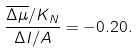Convert formula to latex. <formula><loc_0><loc_0><loc_500><loc_500>\frac { \overline { \Delta \mu } / K _ { N } } { \Delta I / A } = - 0 . 2 0 .</formula> 